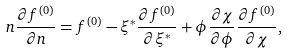Convert formula to latex. <formula><loc_0><loc_0><loc_500><loc_500>n \frac { \partial f ^ { ( 0 ) } } { \partial n } = f ^ { ( 0 ) } - \xi ^ { * } \frac { \partial f ^ { ( 0 ) } } { \partial \xi ^ { * } } + \phi \frac { \partial \chi } { \partial \phi } \frac { \partial f ^ { ( 0 ) } } { \partial \chi } ,</formula> 